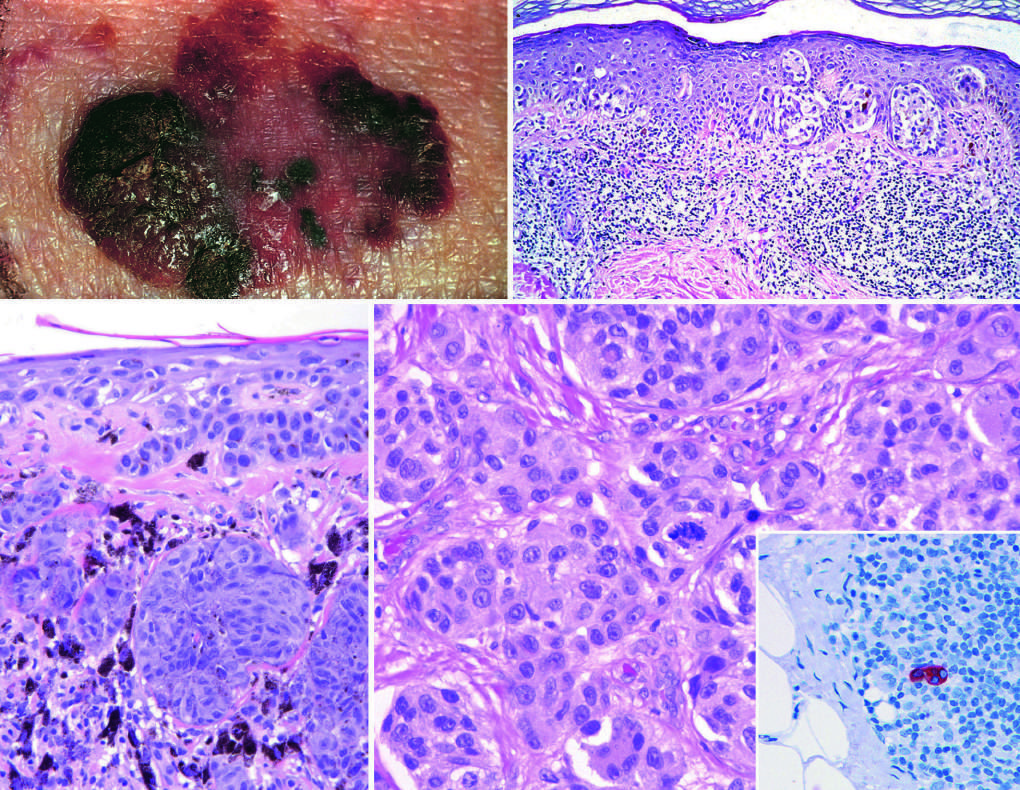what does the inset show?
Answer the question using a single word or phrase. A sentinel lymph node 